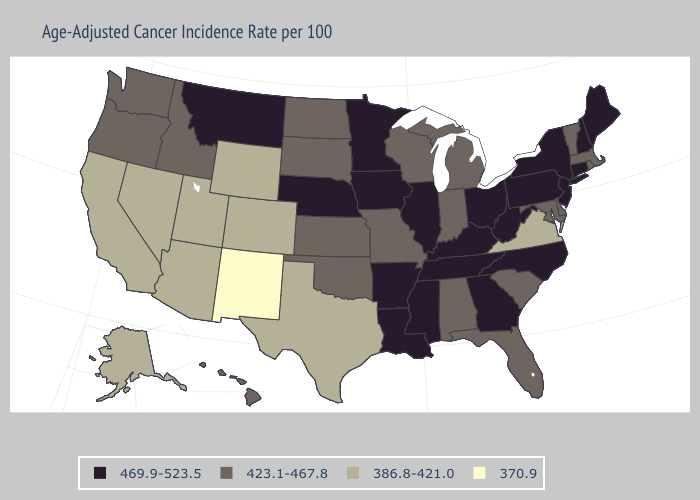What is the highest value in the USA?
Be succinct. 469.9-523.5. Name the states that have a value in the range 469.9-523.5?
Be succinct. Arkansas, Connecticut, Georgia, Illinois, Iowa, Kentucky, Louisiana, Maine, Minnesota, Mississippi, Montana, Nebraska, New Hampshire, New Jersey, New York, North Carolina, Ohio, Pennsylvania, Tennessee, West Virginia. Name the states that have a value in the range 386.8-421.0?
Quick response, please. Alaska, Arizona, California, Colorado, Nevada, Texas, Utah, Virginia, Wyoming. Among the states that border Arizona , which have the highest value?
Give a very brief answer. California, Colorado, Nevada, Utah. Does South Dakota have the same value as Texas?
Concise answer only. No. Which states hav the highest value in the West?
Write a very short answer. Montana. Name the states that have a value in the range 423.1-467.8?
Short answer required. Alabama, Delaware, Florida, Hawaii, Idaho, Indiana, Kansas, Maryland, Massachusetts, Michigan, Missouri, North Dakota, Oklahoma, Oregon, Rhode Island, South Carolina, South Dakota, Vermont, Washington, Wisconsin. Among the states that border New Jersey , does New York have the highest value?
Keep it brief. Yes. Does New Mexico have the lowest value in the USA?
Keep it brief. Yes. Which states hav the highest value in the Northeast?
Quick response, please. Connecticut, Maine, New Hampshire, New Jersey, New York, Pennsylvania. What is the value of Tennessee?
Quick response, please. 469.9-523.5. What is the lowest value in the USA?
Concise answer only. 370.9. What is the lowest value in states that border Florida?
Answer briefly. 423.1-467.8. Does the map have missing data?
Concise answer only. No. What is the value of Utah?
Answer briefly. 386.8-421.0. 